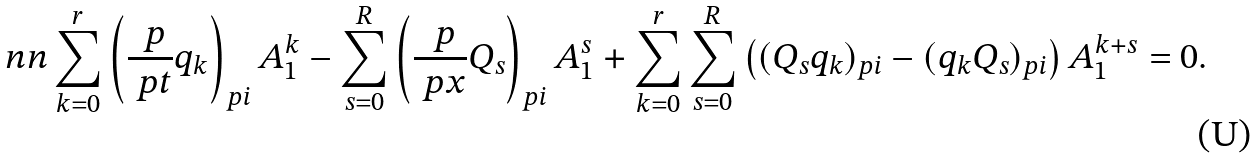<formula> <loc_0><loc_0><loc_500><loc_500>\ n n \sum _ { k = 0 } ^ { r } \left ( \frac { \ p } { \ p t } q _ { k } \right ) _ { p i } A _ { 1 } ^ { k } - \sum _ { s = 0 } ^ { R } \left ( \frac { \ p } { \ p x } Q _ { s } \right ) _ { p i } A _ { 1 } ^ { s } + \sum _ { k = 0 } ^ { r } \sum _ { s = 0 } ^ { R } \left ( ( Q _ { s } q _ { k } ) _ { p i } - ( q _ { k } Q _ { s } ) _ { p i } \right ) A _ { 1 } ^ { k + s } = 0 .</formula> 